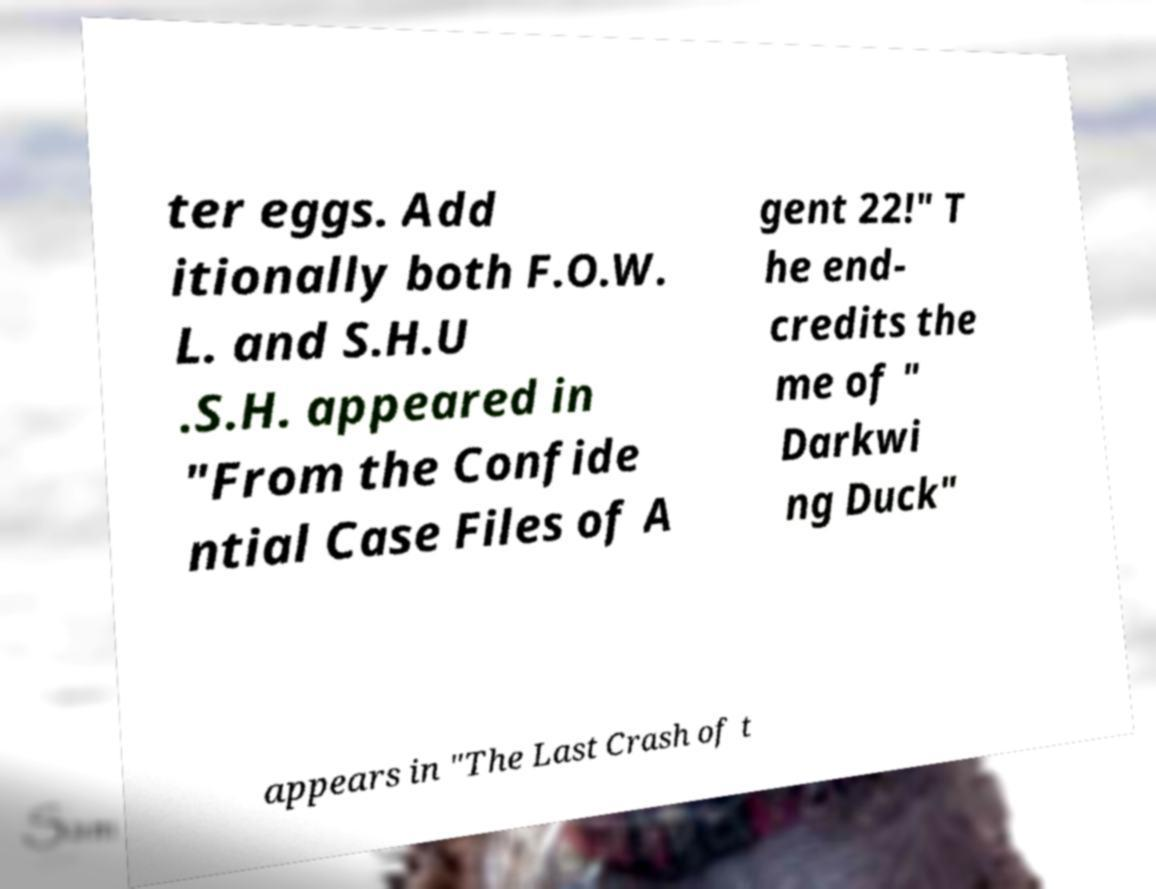What messages or text are displayed in this image? I need them in a readable, typed format. ter eggs. Add itionally both F.O.W. L. and S.H.U .S.H. appeared in "From the Confide ntial Case Files of A gent 22!" T he end- credits the me of " Darkwi ng Duck" appears in "The Last Crash of t 